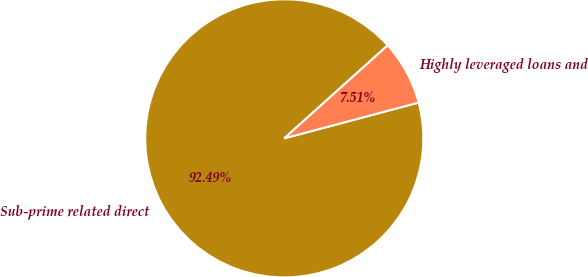<chart> <loc_0><loc_0><loc_500><loc_500><pie_chart><fcel>Sub-prime related direct<fcel>Highly leveraged loans and<nl><fcel>92.49%<fcel>7.51%<nl></chart> 